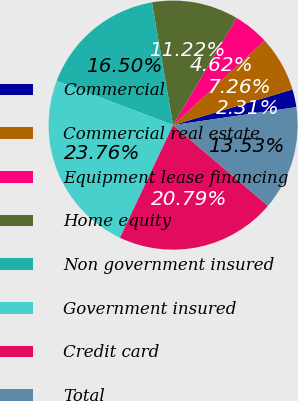Convert chart. <chart><loc_0><loc_0><loc_500><loc_500><pie_chart><fcel>Commercial<fcel>Commercial real estate<fcel>Equipment lease financing<fcel>Home equity<fcel>Non government insured<fcel>Government insured<fcel>Credit card<fcel>Total<nl><fcel>2.31%<fcel>7.26%<fcel>4.62%<fcel>11.22%<fcel>16.5%<fcel>23.76%<fcel>20.79%<fcel>13.53%<nl></chart> 